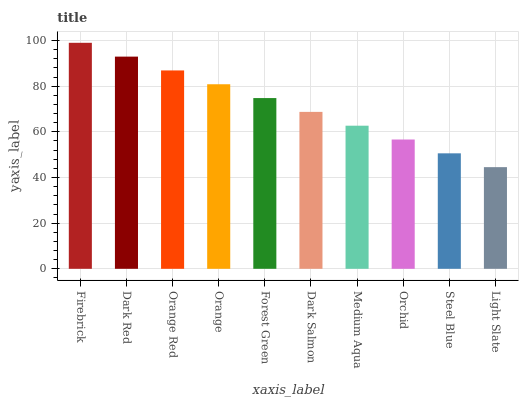Is Firebrick the maximum?
Answer yes or no. Yes. Is Dark Red the minimum?
Answer yes or no. No. Is Dark Red the maximum?
Answer yes or no. No. Is Firebrick greater than Dark Red?
Answer yes or no. Yes. Is Dark Red less than Firebrick?
Answer yes or no. Yes. Is Dark Red greater than Firebrick?
Answer yes or no. No. Is Firebrick less than Dark Red?
Answer yes or no. No. Is Forest Green the high median?
Answer yes or no. Yes. Is Dark Salmon the low median?
Answer yes or no. Yes. Is Steel Blue the high median?
Answer yes or no. No. Is Medium Aqua the low median?
Answer yes or no. No. 